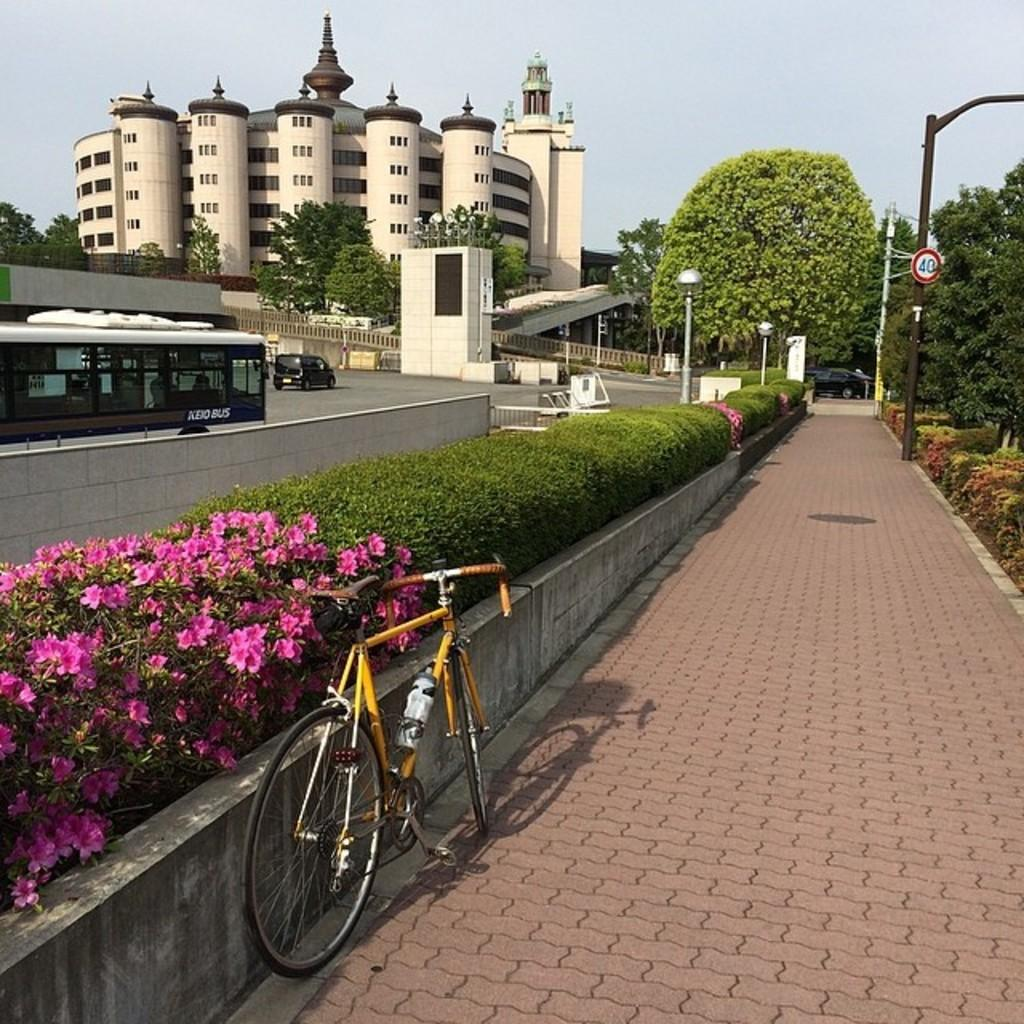What type of vehicle can be seen in the image? There are vehicles in the image, but the specific type cannot be determined from the provided facts. What is the primary mode of transportation in the image? The primary mode of transportation in the image is a cycle. What type of vegetation is present in the image? There are flowers, plants, and trees in the image. What type of infrastructure is present in the image? There are street lights, a pole, a sign board, a road, and buildings in the image. What is visible in the sky in the image? The sky is visible in the image, but no specific details about the sky can be determined from the provided facts. What is the price of the book on the cycle in the image? There is no book or price mentioned in the image. How many thumbs can be seen on the cyclist in the image? There is no cyclist or thumb visible in the image. 